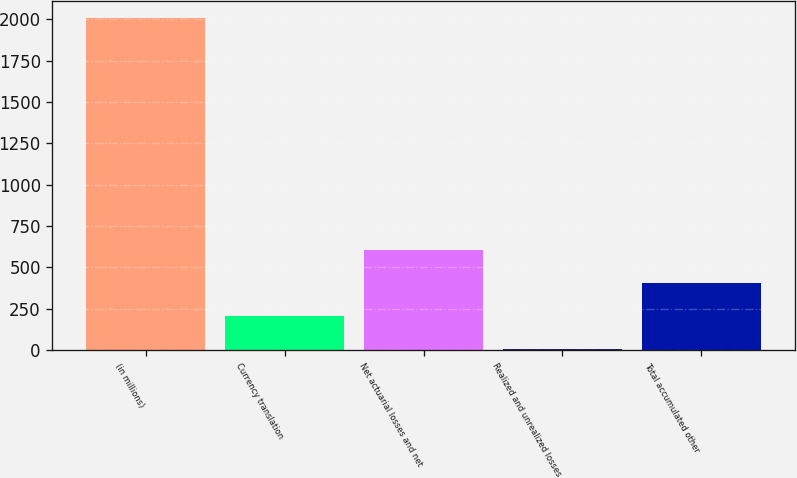Convert chart to OTSL. <chart><loc_0><loc_0><loc_500><loc_500><bar_chart><fcel>(in millions)<fcel>Currency translation<fcel>Net actuarial losses and net<fcel>Realized and unrealized losses<fcel>Total accumulated other<nl><fcel>2009<fcel>206.57<fcel>607.11<fcel>6.3<fcel>406.84<nl></chart> 